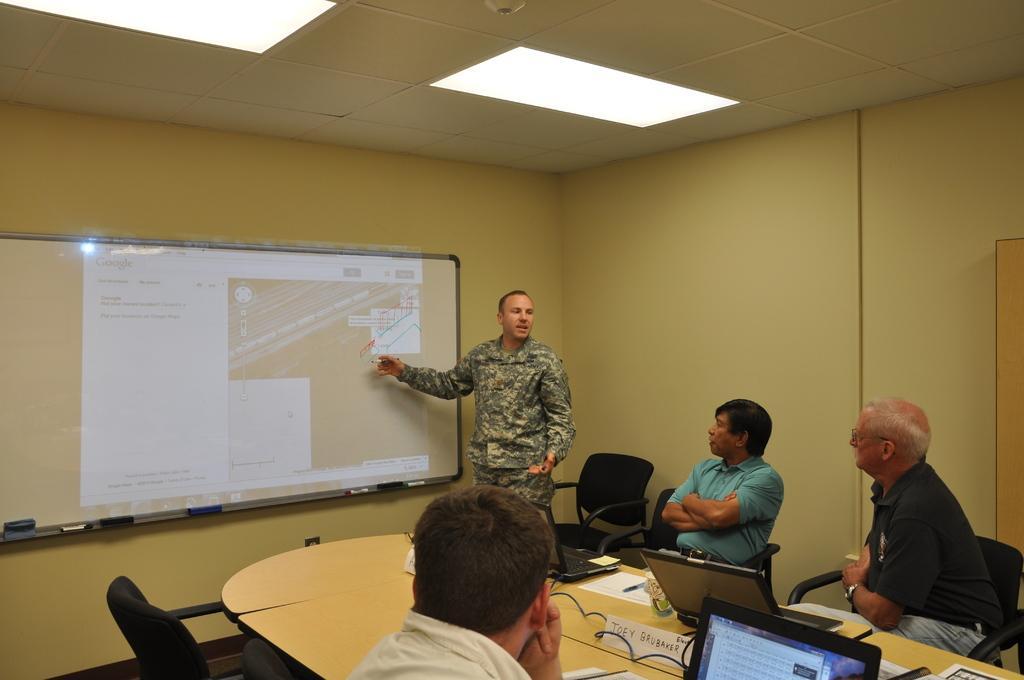Please provide a concise description of this image. At the top we can see ceiling and lights. We can see a board and reflection of screen on a board. We can see one man standing and explaining. We can see three men sitting on chairs in front of a table and on the table we can see board, laptops,pen and paper. This is a door. 